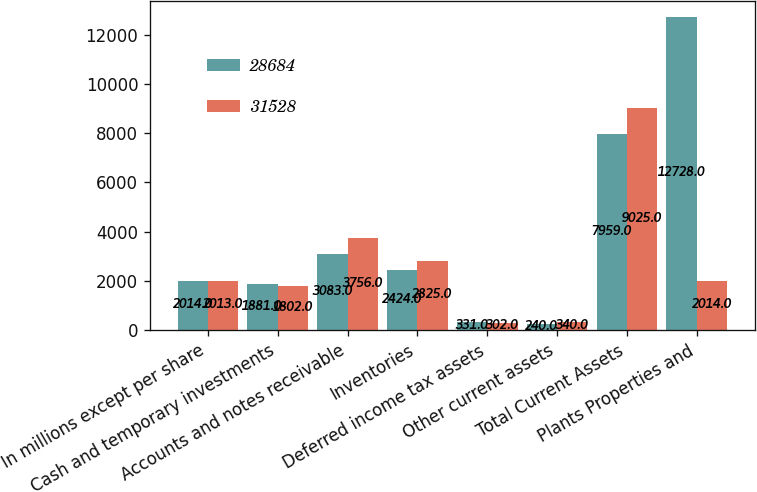Convert chart to OTSL. <chart><loc_0><loc_0><loc_500><loc_500><stacked_bar_chart><ecel><fcel>In millions except per share<fcel>Cash and temporary investments<fcel>Accounts and notes receivable<fcel>Inventories<fcel>Deferred income tax assets<fcel>Other current assets<fcel>Total Current Assets<fcel>Plants Properties and<nl><fcel>28684<fcel>2014<fcel>1881<fcel>3083<fcel>2424<fcel>331<fcel>240<fcel>7959<fcel>12728<nl><fcel>31528<fcel>2013<fcel>1802<fcel>3756<fcel>2825<fcel>302<fcel>340<fcel>9025<fcel>2014<nl></chart> 